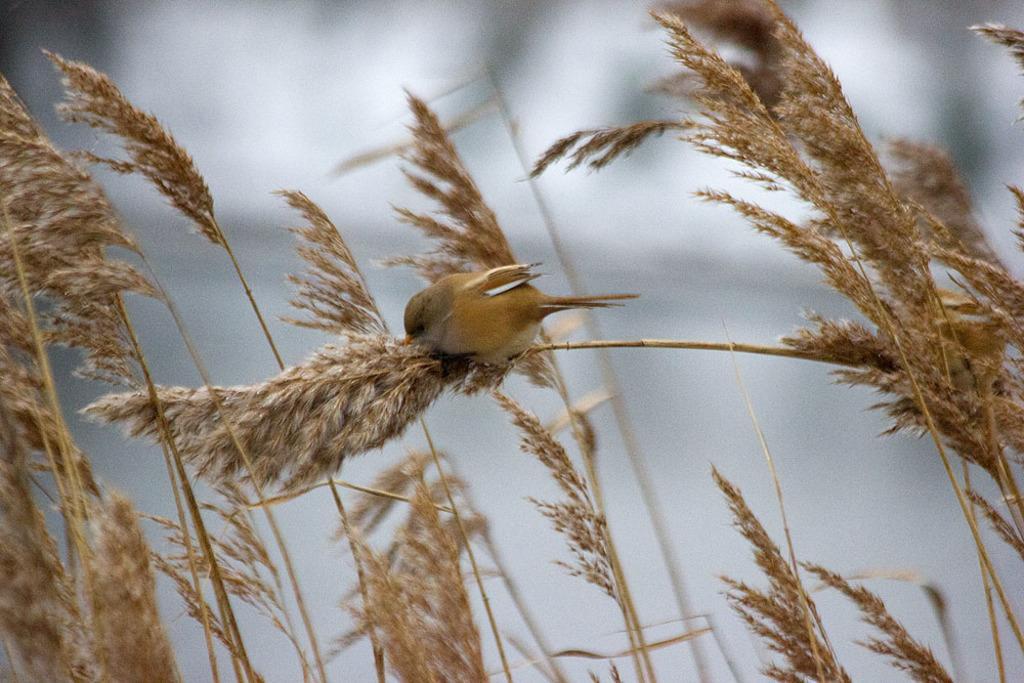Please provide a concise description of this image. There is a bird on the plants. The background is blurred. 